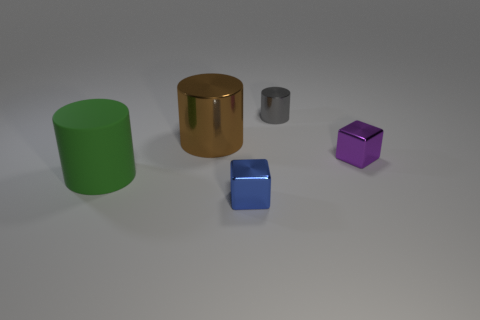Subtract all purple cubes. Subtract all brown spheres. How many cubes are left? 1 Add 4 large yellow matte cubes. How many objects exist? 9 Subtract all cylinders. How many objects are left? 2 Add 1 purple matte cylinders. How many purple matte cylinders exist? 1 Subtract 0 brown balls. How many objects are left? 5 Subtract all small purple cubes. Subtract all red rubber spheres. How many objects are left? 4 Add 1 small blue metal blocks. How many small blue metal blocks are left? 2 